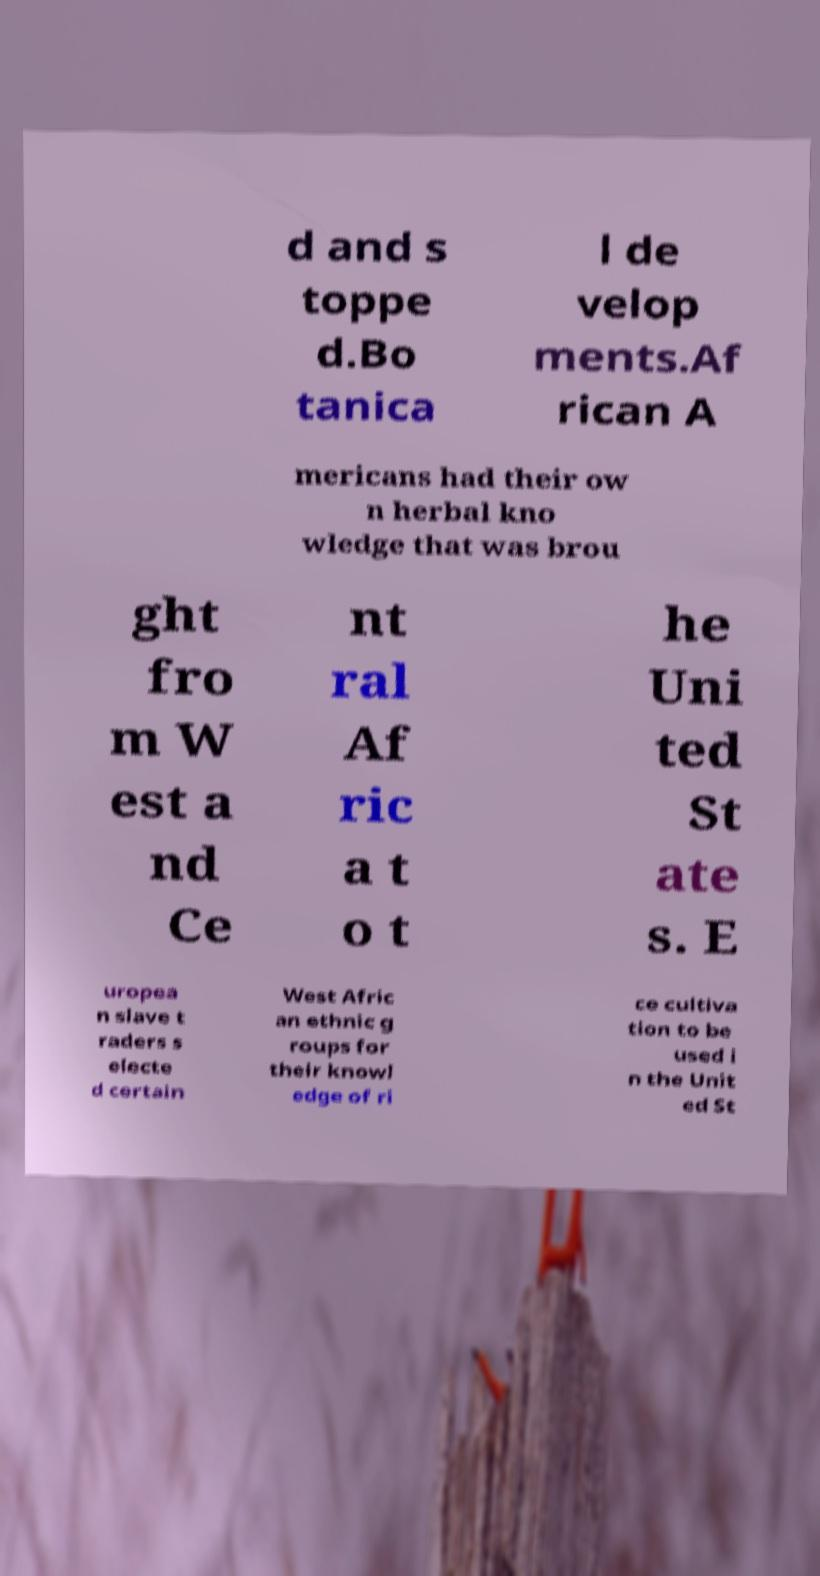There's text embedded in this image that I need extracted. Can you transcribe it verbatim? d and s toppe d.Bo tanica l de velop ments.Af rican A mericans had their ow n herbal kno wledge that was brou ght fro m W est a nd Ce nt ral Af ric a t o t he Uni ted St ate s. E uropea n slave t raders s electe d certain West Afric an ethnic g roups for their knowl edge of ri ce cultiva tion to be used i n the Unit ed St 